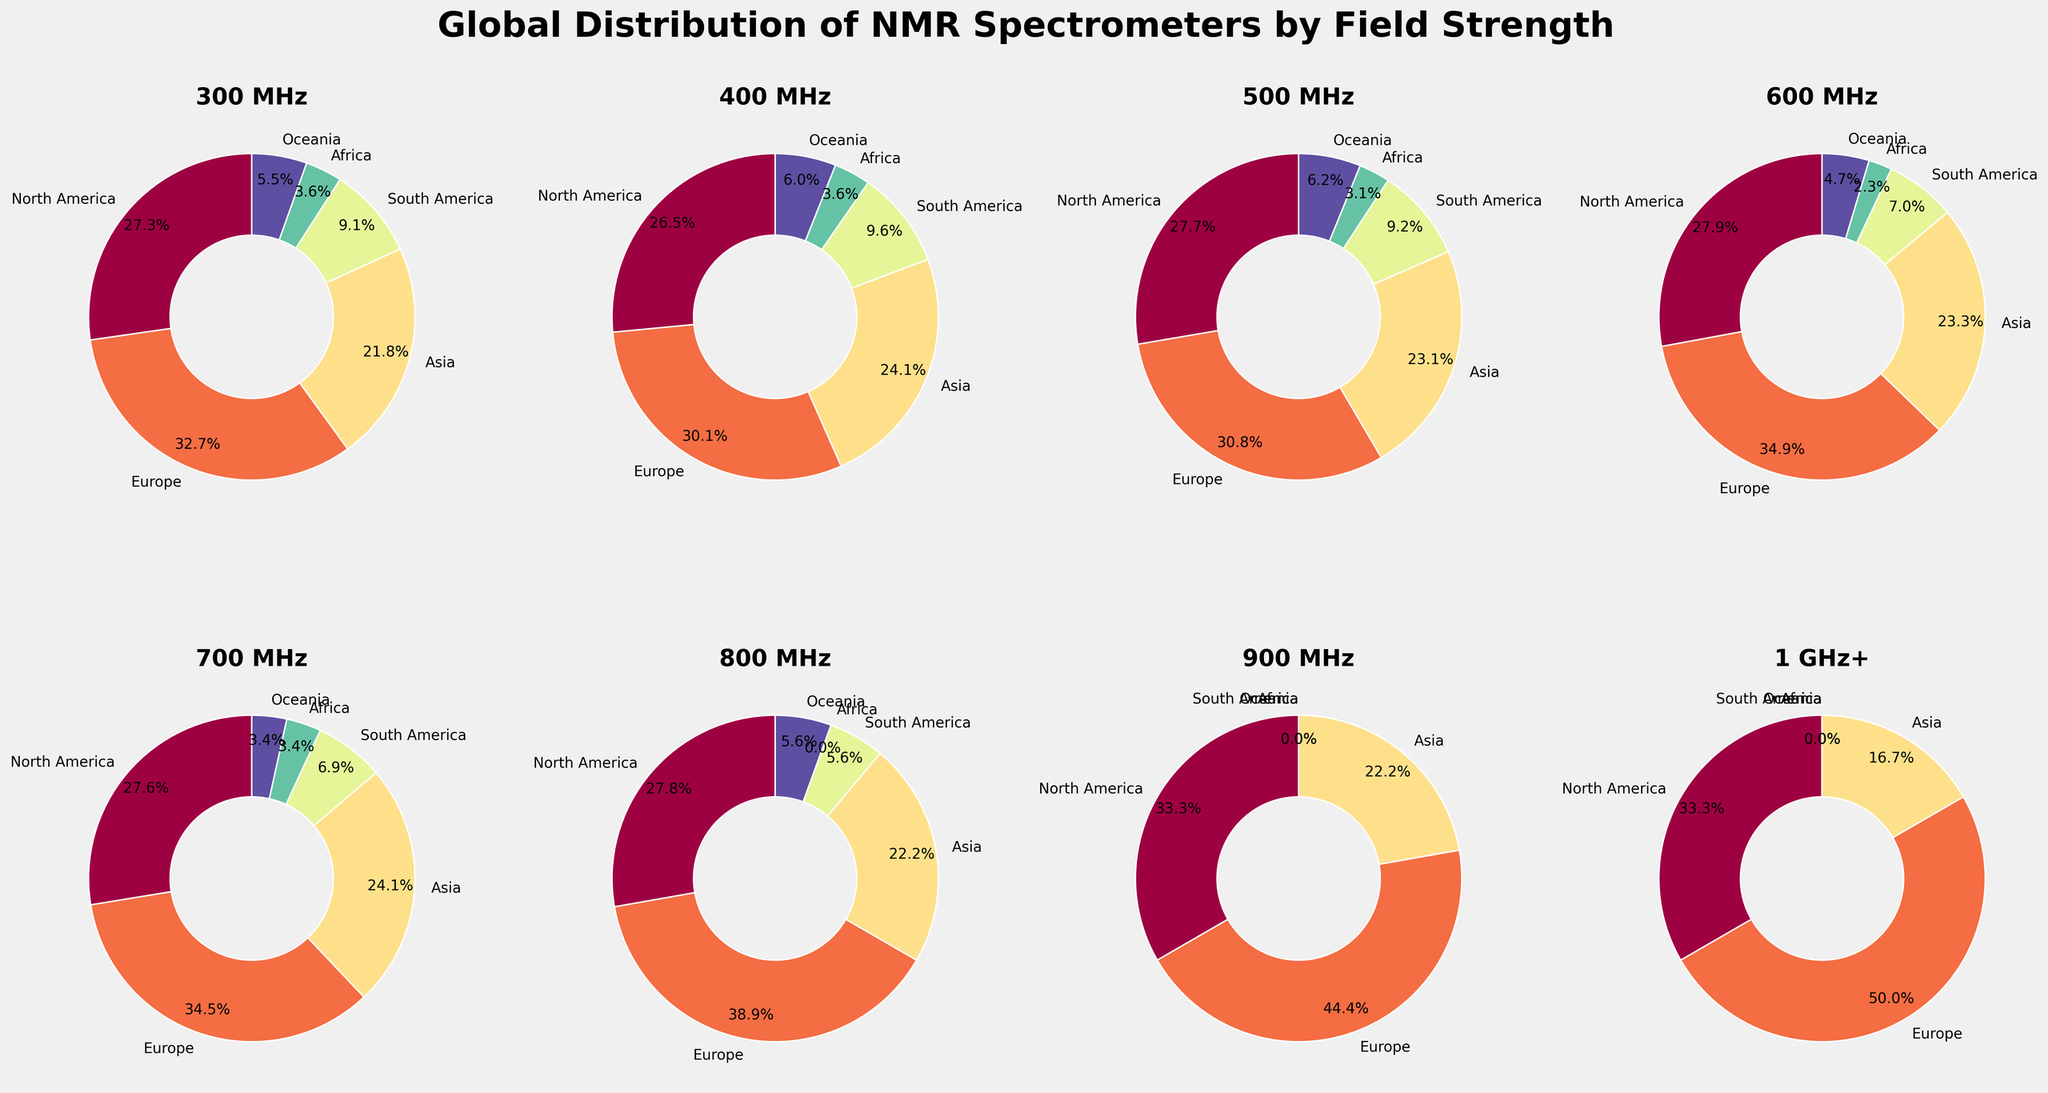Which field strength has the highest percentage of NMR spectrometers in North America? Look at the slices representing North America in the pie charts. The largest slice for North America is at 400 MHz.
Answer: 400 MHz Which region has the least distribution of 900 MHz spectrometers? Identify the smallest slice for the 900 MHz pie chart. Africa, South America, and Oceania all have 0%.
Answer: Africa, South America, Oceania How does the distribution of 700 MHz spectrometers in Asia compare to that in Europe? Compare the slices labeled "Asia" and "Europe" in the 700 MHz pie chart. Both Asia and Europe have small slices, but Europe's slice is slightly larger.
Answer: Asia is less than Europe What's the total number of spectrometers with 800 MHz field strength across all regions? Sum the values for each region at 800 MHz: 5 + 7 + 4 + 1 + 0 + 1 = 18.
Answer: 18 Which field strength has the smallest percentage of spectrometers in Oceania? Look at all the pie charts and find the one with the smallest slice for Oceania. The slices for 900 MHz and 1 GHz+ both have value 0.
Answer: 900 MHz and 1 GHz+ Which continent shows the most balanced distribution across various field strengths? Evaluate which continent has the most equally-sized slices across multiple pie charts. Europe has relatively balanced slices.
Answer: Europe For 500 MHz spectrometers, compare the percentage distributions between North America and South America. Look at the slices for North America and South America in the 500 MHz pie chart. North America has a significantly larger slice compared to South America.
Answer: North America is more than South America What is the average number of spectrometers in South America for field strengths of 600 MHz and above? Calculate the average from the data set: (3 + 2 + 1 + 0 + 0)/5 = 6/5 = 1.2.
Answer: 1.2 Which region has the highest total number of spectrometers across all field strengths? Sum the spectrometer numbers for each region across all field strengths and compare. Europe has the highest total sum.
Answer: Europe What is the difference in the number of spectrometers with 400 MHz field strength between North America and Asia? Subtract the number of spectrometers in Asia from North America: 22 - 20 = 2.
Answer: 2 